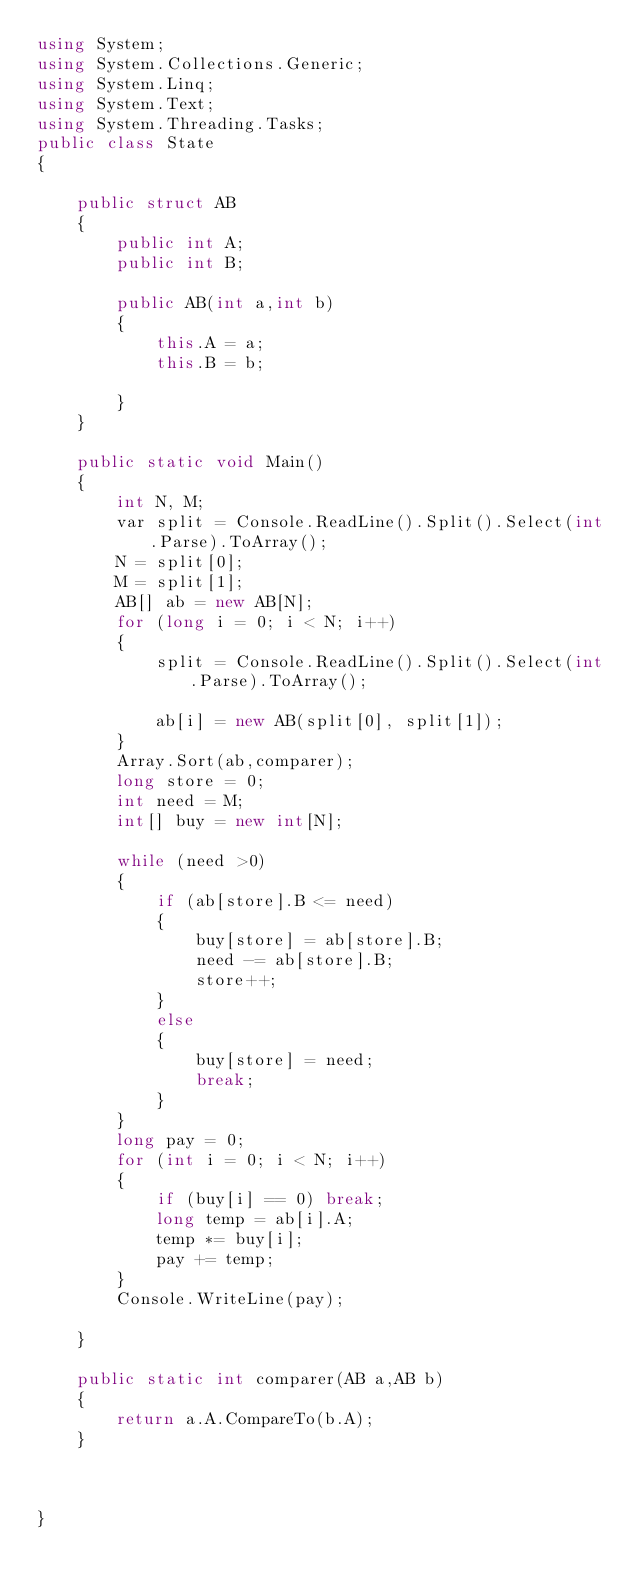Convert code to text. <code><loc_0><loc_0><loc_500><loc_500><_C#_>using System;
using System.Collections.Generic;
using System.Linq;
using System.Text;
using System.Threading.Tasks;
public class State
{

    public struct AB
    {
        public int A;
        public int B;

        public AB(int a,int b)
        {
            this.A = a;
            this.B = b;

        }
    }

    public static void Main()
    {
        int N, M;
        var split = Console.ReadLine().Split().Select(int.Parse).ToArray();
        N = split[0];
        M = split[1];
        AB[] ab = new AB[N];
        for (long i = 0; i < N; i++)
        {
            split = Console.ReadLine().Split().Select(int.Parse).ToArray();

            ab[i] = new AB(split[0], split[1]);
        }
        Array.Sort(ab,comparer);
        long store = 0;
        int need = M;
        int[] buy = new int[N];

        while (need >0)
        {
            if (ab[store].B <= need)
            {
                buy[store] = ab[store].B;
                need -= ab[store].B;
                store++;
            }
            else
            {
                buy[store] = need;
                break;
            }
        }
        long pay = 0;
        for (int i = 0; i < N; i++)
        {
            if (buy[i] == 0) break;
            long temp = ab[i].A;
            temp *= buy[i];
            pay += temp;
        }
        Console.WriteLine(pay);

    }

    public static int comparer(AB a,AB b)
    {
        return a.A.CompareTo(b.A);
    }



}

</code> 